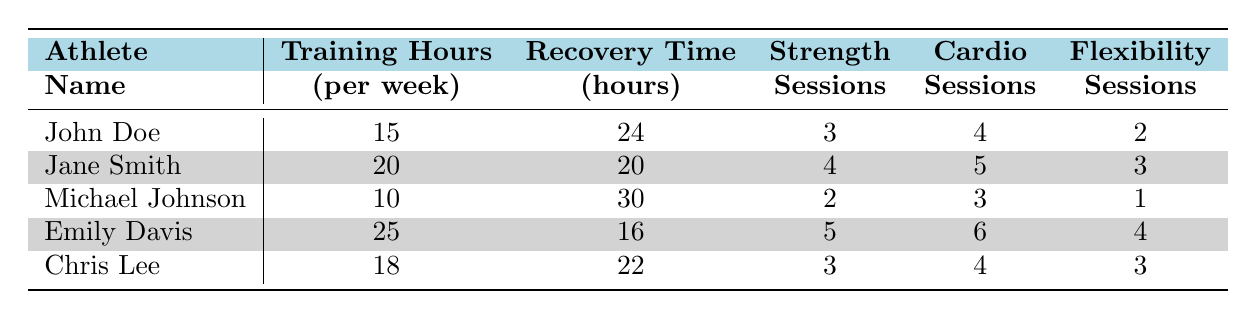What is the Recovery Time for Emily Davis? Emily Davis's Recovery Time is listed in the table under the "Recovery Time" column, which states it as 16 hours.
Answer: 16 hours What is the highest number of Training Hours per Week among the athletes? The "Training Hours" column shows the following values: 15, 20, 10, 25, and 18. Among these, 25 is the highest value, associated with Emily Davis.
Answer: 25 Does Michael Johnson have the most sessions of Strength Training? The "Strength Training Session" data shows Michael Johnson at 2 sessions, which is lower than others: John Doe (3), Jane Smith (4), Emily Davis (5), and Chris Lee (3). Hence, the answer is no.
Answer: No What is the average Recovery Time for the athletes? The Recovery Times are 24, 20, 30, 16, and 22 hours. Adding them gives a total of 24 + 20 + 30 + 16 + 22 = 112. Dividing by 5 athletes gives an average of 112 / 5 = 22.4 hours.
Answer: 22.4 hours Which athlete has the highest number of Cardio Sessions? The "Cardio Session" values are: 4, 5, 3, 6, and 4. The highest value is 6, which corresponds to Emily Davis.
Answer: Emily Davis What is the Recovery Time difference between John Doe and Jane Smith? John Doe's Recovery Time is 24 hours and Jane Smith's Recovery Time is 20 hours. The difference is calculated as 24 - 20 = 4 hours.
Answer: 4 hours Which athlete trained the least number of Training Hours per Week? The "Training Hours" column indicates the following: 15, 20, 10, 25, and 18. The lowest value is 10, associated with Michael Johnson.
Answer: Michael Johnson Is there any athlete with the same number of Flexibility Sessions? The "Flexibility Session" values are 2, 3, 1, 4, and 3. The numbers 3 appear for both Jane Smith and Chris Lee, thus confirming this statement as true.
Answer: Yes Which athlete has the lowest recovery time per training hour based on the data? To find the lowest recovery time per training hour, divide each athlete's Recovery Time by their Training Hours: John Doe (24/15 = 1.6), Jane Smith (20/20 = 1), Michael Johnson (30/10 = 3), Emily Davis (16/25 = 0.64), Chris Lee (22/18 = 1.22). Emily Davis has the lowest value of 0.64.
Answer: Emily Davis 